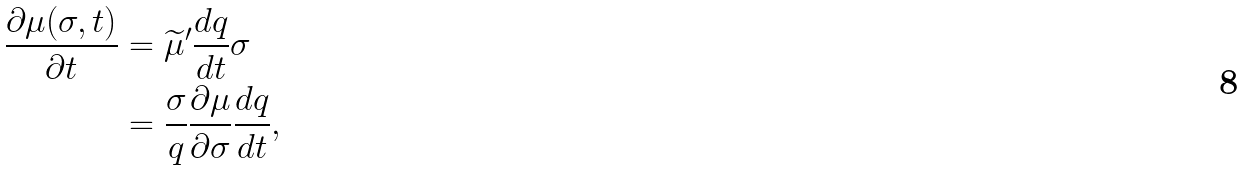Convert formula to latex. <formula><loc_0><loc_0><loc_500><loc_500>\frac { \partial \mu ( \sigma , t ) } { \partial t } & = \widetilde { \mu } ^ { \prime } \frac { d q } { d t } \sigma \\ & = \frac { \sigma } { q } \frac { \partial \mu } { \partial \sigma } \frac { d q } { d t } ,</formula> 